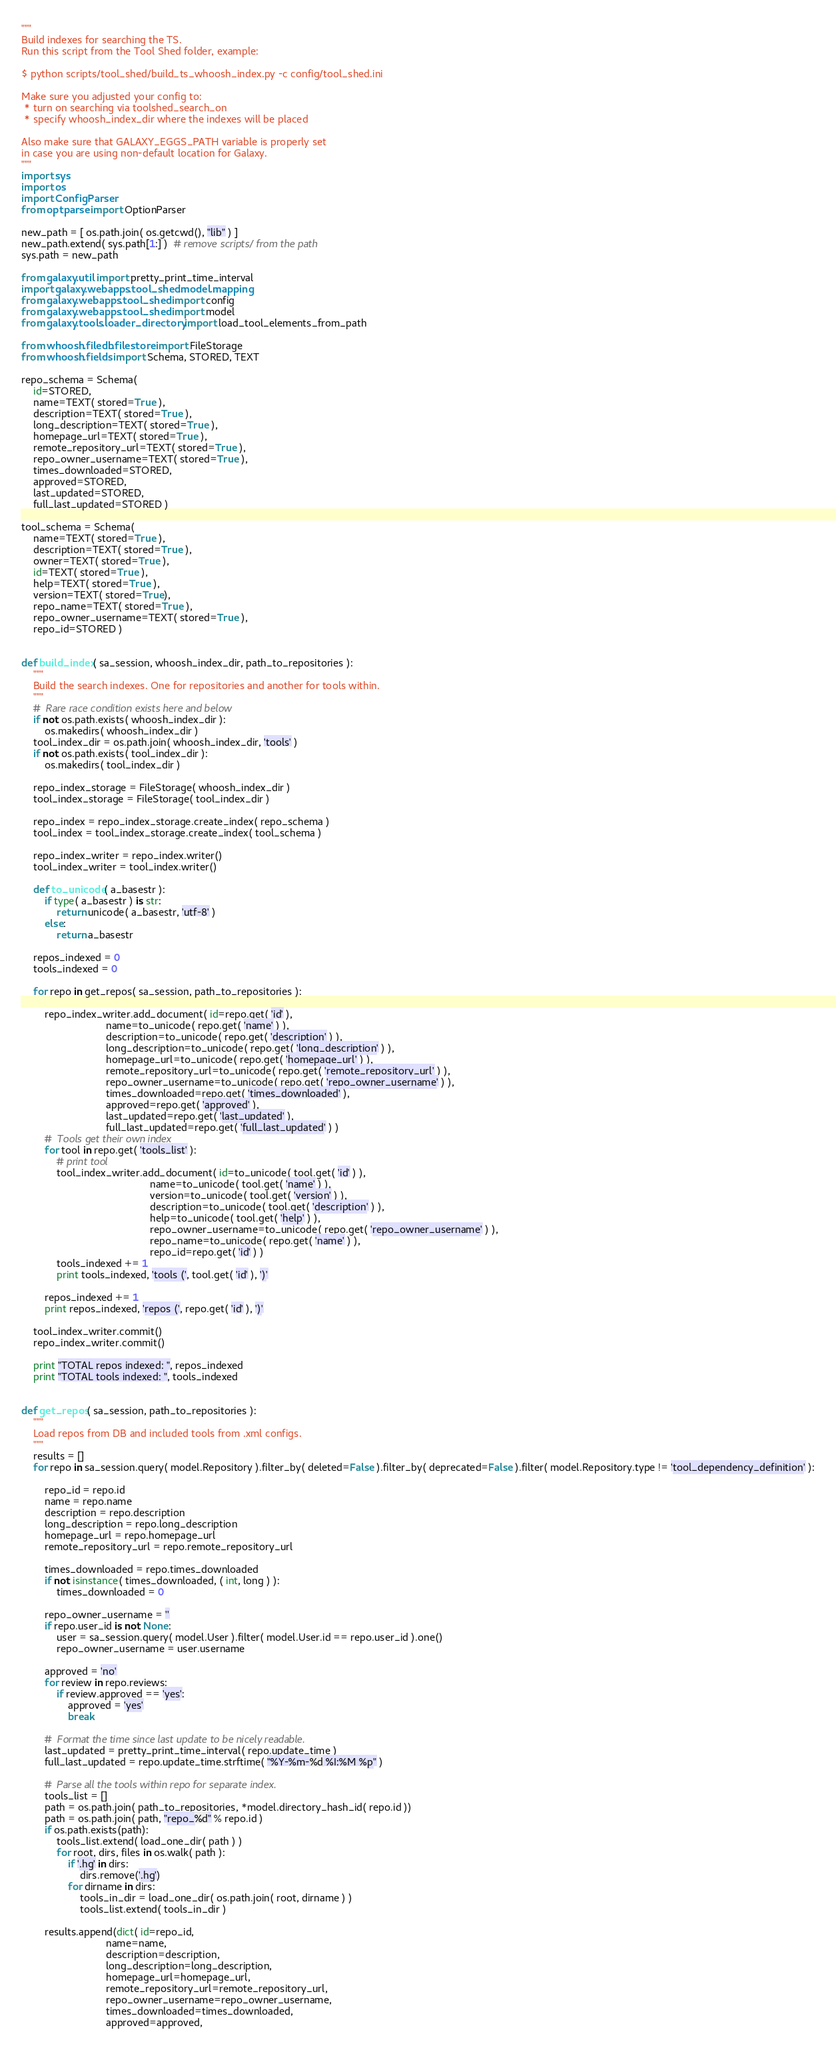<code> <loc_0><loc_0><loc_500><loc_500><_Python_>"""
Build indexes for searching the TS.
Run this script from the Tool Shed folder, example:

$ python scripts/tool_shed/build_ts_whoosh_index.py -c config/tool_shed.ini

Make sure you adjusted your config to:
 * turn on searching via toolshed_search_on
 * specify whoosh_index_dir where the indexes will be placed

Also make sure that GALAXY_EGGS_PATH variable is properly set
in case you are using non-default location for Galaxy.
"""
import sys
import os
import ConfigParser
from optparse import OptionParser

new_path = [ os.path.join( os.getcwd(), "lib" ) ]
new_path.extend( sys.path[1:] )  # remove scripts/ from the path
sys.path = new_path

from galaxy.util import pretty_print_time_interval
import galaxy.webapps.tool_shed.model.mapping
from galaxy.webapps.tool_shed import config
from galaxy.webapps.tool_shed import model
from galaxy.tools.loader_directory import load_tool_elements_from_path

from whoosh.filedb.filestore import FileStorage
from whoosh.fields import Schema, STORED, TEXT

repo_schema = Schema(
    id=STORED,
    name=TEXT( stored=True ),
    description=TEXT( stored=True ),
    long_description=TEXT( stored=True ),
    homepage_url=TEXT( stored=True ),
    remote_repository_url=TEXT( stored=True ),
    repo_owner_username=TEXT( stored=True ),
    times_downloaded=STORED,
    approved=STORED,
    last_updated=STORED,
    full_last_updated=STORED )

tool_schema = Schema(
    name=TEXT( stored=True ),
    description=TEXT( stored=True ),
    owner=TEXT( stored=True ),
    id=TEXT( stored=True ),
    help=TEXT( stored=True ),
    version=TEXT( stored=True),
    repo_name=TEXT( stored=True ),
    repo_owner_username=TEXT( stored=True ),
    repo_id=STORED )


def build_index( sa_session, whoosh_index_dir, path_to_repositories ):
    """
    Build the search indexes. One for repositories and another for tools within.
    """
    #  Rare race condition exists here and below
    if not os.path.exists( whoosh_index_dir ):
        os.makedirs( whoosh_index_dir )
    tool_index_dir = os.path.join( whoosh_index_dir, 'tools' )
    if not os.path.exists( tool_index_dir ):
        os.makedirs( tool_index_dir )

    repo_index_storage = FileStorage( whoosh_index_dir )
    tool_index_storage = FileStorage( tool_index_dir )

    repo_index = repo_index_storage.create_index( repo_schema )
    tool_index = tool_index_storage.create_index( tool_schema )

    repo_index_writer = repo_index.writer()
    tool_index_writer = tool_index.writer()

    def to_unicode( a_basestr ):
        if type( a_basestr ) is str:
            return unicode( a_basestr, 'utf-8' )
        else:
            return a_basestr

    repos_indexed = 0
    tools_indexed = 0

    for repo in get_repos( sa_session, path_to_repositories ):

        repo_index_writer.add_document( id=repo.get( 'id' ),
                             name=to_unicode( repo.get( 'name' ) ),
                             description=to_unicode( repo.get( 'description' ) ),
                             long_description=to_unicode( repo.get( 'long_description' ) ),
                             homepage_url=to_unicode( repo.get( 'homepage_url' ) ),
                             remote_repository_url=to_unicode( repo.get( 'remote_repository_url' ) ),
                             repo_owner_username=to_unicode( repo.get( 'repo_owner_username' ) ),
                             times_downloaded=repo.get( 'times_downloaded' ),
                             approved=repo.get( 'approved' ),
                             last_updated=repo.get( 'last_updated' ),
                             full_last_updated=repo.get( 'full_last_updated' ) )
        #  Tools get their own index
        for tool in repo.get( 'tools_list' ):
            # print tool
            tool_index_writer.add_document( id=to_unicode( tool.get( 'id' ) ),
                                            name=to_unicode( tool.get( 'name' ) ),
                                            version=to_unicode( tool.get( 'version' ) ),
                                            description=to_unicode( tool.get( 'description' ) ),
                                            help=to_unicode( tool.get( 'help' ) ),
                                            repo_owner_username=to_unicode( repo.get( 'repo_owner_username' ) ),
                                            repo_name=to_unicode( repo.get( 'name' ) ),
                                            repo_id=repo.get( 'id' ) )
            tools_indexed += 1
            print tools_indexed, 'tools (', tool.get( 'id' ), ')'

        repos_indexed += 1
        print repos_indexed, 'repos (', repo.get( 'id' ), ')'

    tool_index_writer.commit()
    repo_index_writer.commit()

    print "TOTAL repos indexed: ", repos_indexed
    print "TOTAL tools indexed: ", tools_indexed


def get_repos( sa_session, path_to_repositories ):
    """
    Load repos from DB and included tools from .xml configs.
    """
    results = []
    for repo in sa_session.query( model.Repository ).filter_by( deleted=False ).filter_by( deprecated=False ).filter( model.Repository.type != 'tool_dependency_definition' ):

        repo_id = repo.id
        name = repo.name
        description = repo.description
        long_description = repo.long_description
        homepage_url = repo.homepage_url
        remote_repository_url = repo.remote_repository_url

        times_downloaded = repo.times_downloaded
        if not isinstance( times_downloaded, ( int, long ) ):
            times_downloaded = 0

        repo_owner_username = ''
        if repo.user_id is not None:
            user = sa_session.query( model.User ).filter( model.User.id == repo.user_id ).one()
            repo_owner_username = user.username

        approved = 'no'
        for review in repo.reviews:
            if review.approved == 'yes':
                approved = 'yes'
                break

        #  Format the time since last update to be nicely readable.
        last_updated = pretty_print_time_interval( repo.update_time )
        full_last_updated = repo.update_time.strftime( "%Y-%m-%d %I:%M %p" )

        #  Parse all the tools within repo for separate index.
        tools_list = []
        path = os.path.join( path_to_repositories, *model.directory_hash_id( repo.id ))
        path = os.path.join( path, "repo_%d" % repo.id )
        if os.path.exists(path):
            tools_list.extend( load_one_dir( path ) )
            for root, dirs, files in os.walk( path ):
                if '.hg' in dirs:
                    dirs.remove('.hg')
                for dirname in dirs:
                    tools_in_dir = load_one_dir( os.path.join( root, dirname ) )
                    tools_list.extend( tools_in_dir )

        results.append(dict( id=repo_id,
                             name=name,
                             description=description,
                             long_description=long_description,
                             homepage_url=homepage_url,
                             remote_repository_url=remote_repository_url,
                             repo_owner_username=repo_owner_username,
                             times_downloaded=times_downloaded,
                             approved=approved,</code> 